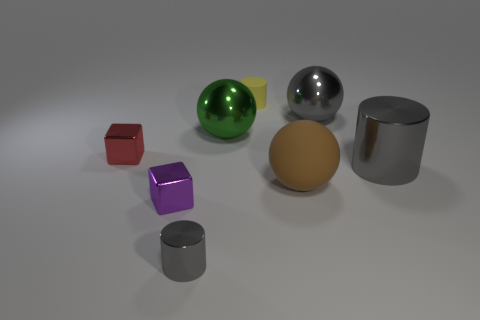Subtract all gray metal balls. How many balls are left? 2 Subtract all brown blocks. How many gray cylinders are left? 2 Add 1 green matte things. How many objects exist? 9 Subtract all blue balls. Subtract all purple cylinders. How many balls are left? 3 Subtract all spheres. How many objects are left? 5 Subtract all large green balls. Subtract all big brown matte balls. How many objects are left? 6 Add 4 tiny purple objects. How many tiny purple objects are left? 5 Add 2 red things. How many red things exist? 3 Subtract 0 red cylinders. How many objects are left? 8 